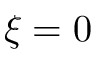Convert formula to latex. <formula><loc_0><loc_0><loc_500><loc_500>\xi = 0</formula> 